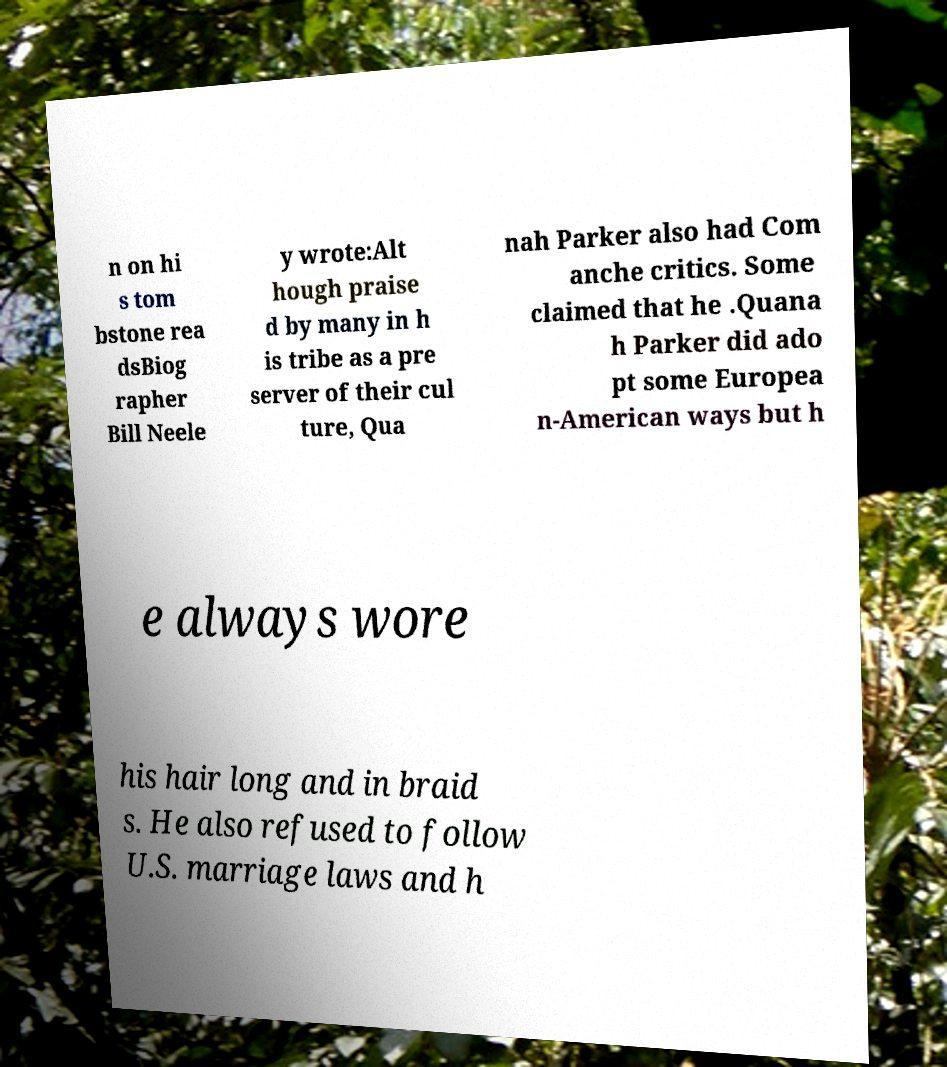Please identify and transcribe the text found in this image. n on hi s tom bstone rea dsBiog rapher Bill Neele y wrote:Alt hough praise d by many in h is tribe as a pre server of their cul ture, Qua nah Parker also had Com anche critics. Some claimed that he .Quana h Parker did ado pt some Europea n-American ways but h e always wore his hair long and in braid s. He also refused to follow U.S. marriage laws and h 